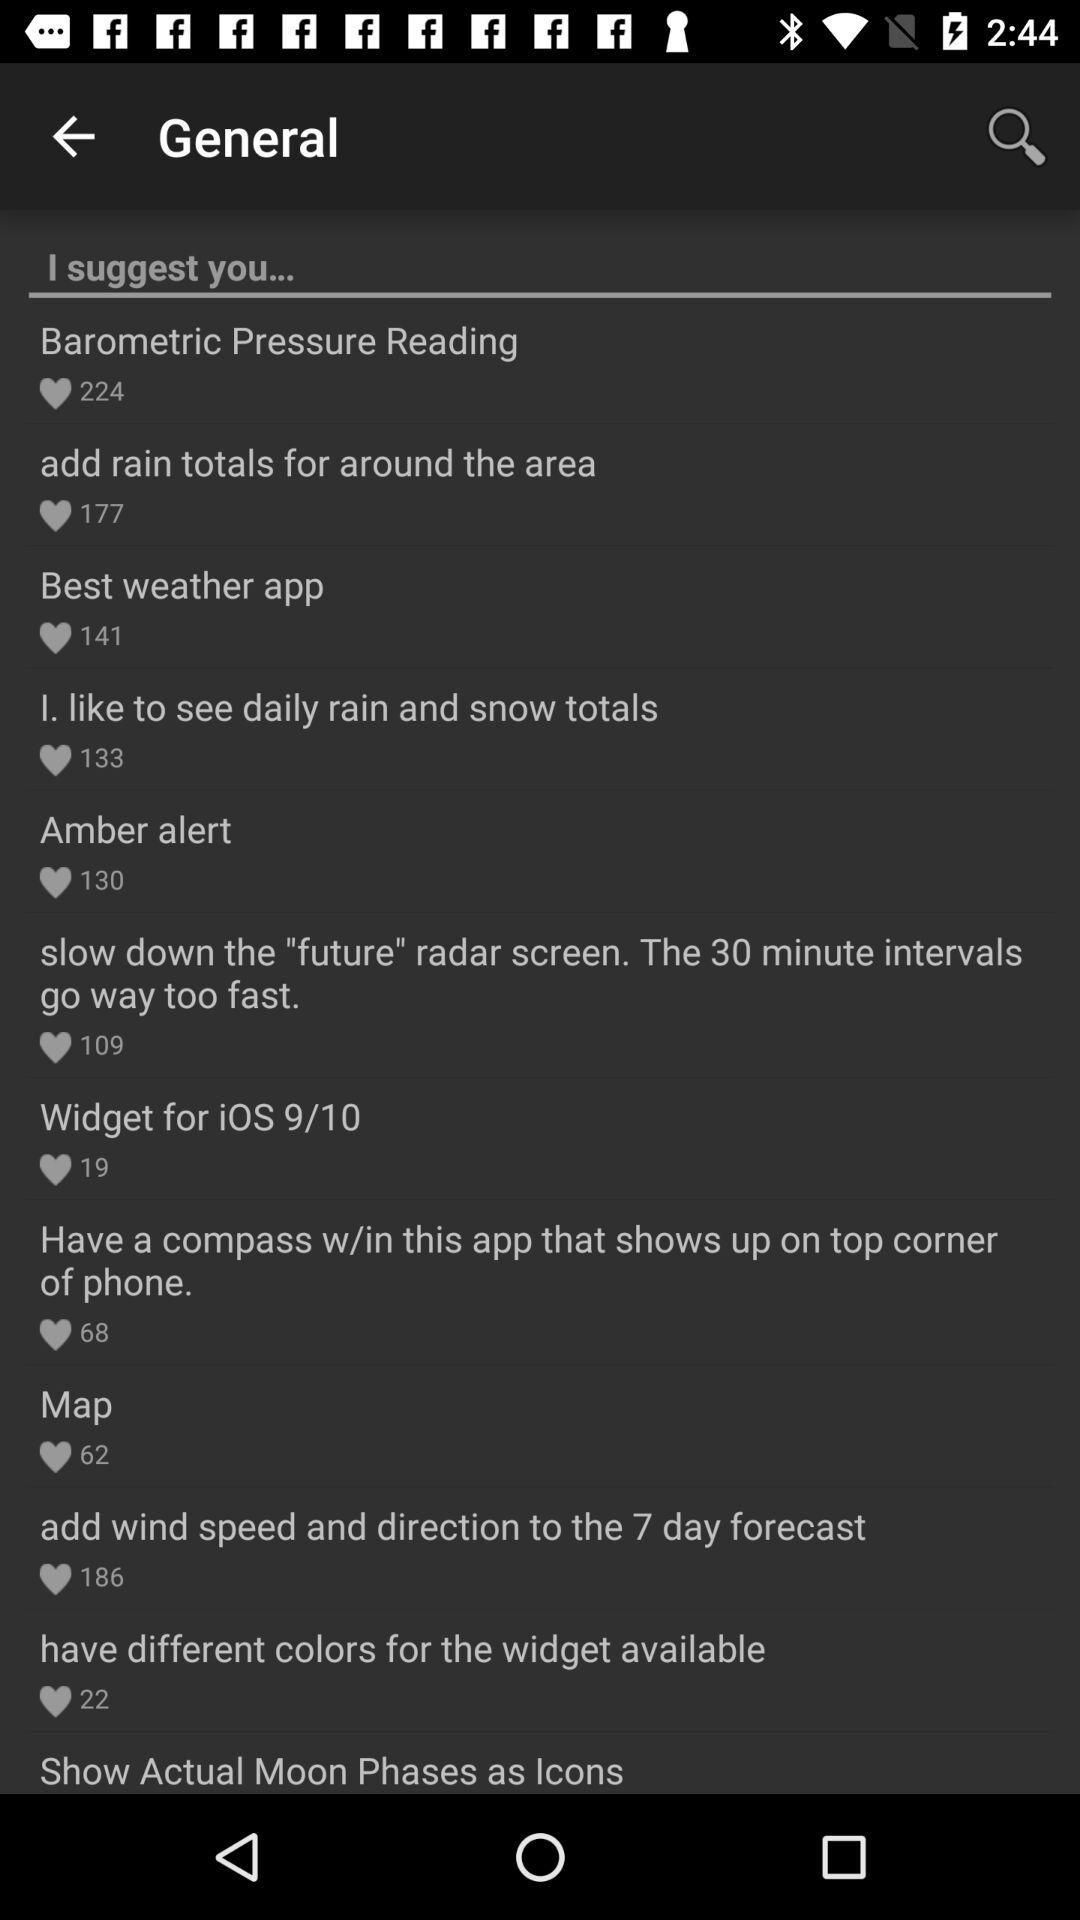How many people like "Map"? "Map" is liked by 62 people. 